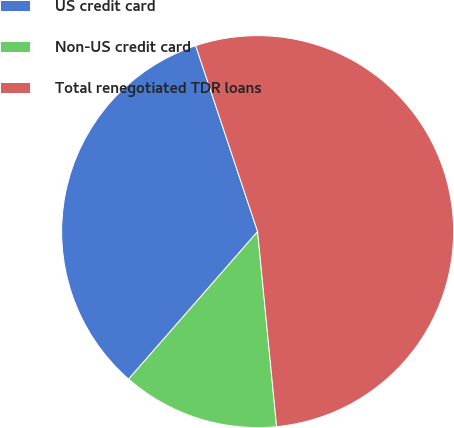<chart> <loc_0><loc_0><loc_500><loc_500><pie_chart><fcel>US credit card<fcel>Non-US credit card<fcel>Total renegotiated TDR loans<nl><fcel>33.44%<fcel>12.98%<fcel>53.57%<nl></chart> 